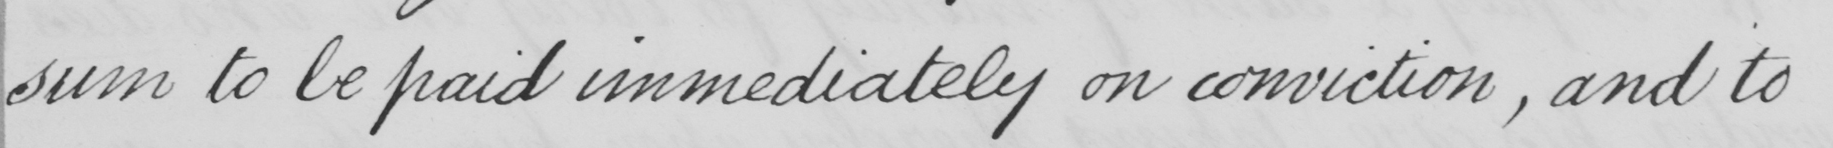Transcribe the text shown in this historical manuscript line. sum to be paid immediately on conviction , and to 